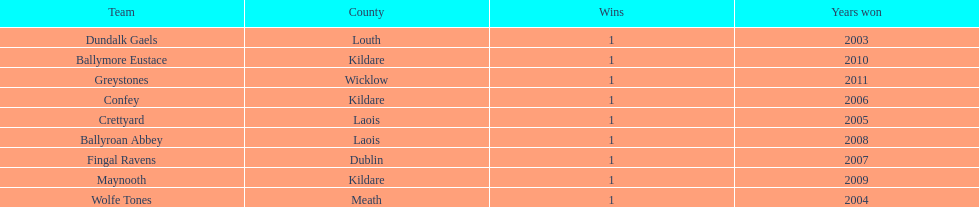Help me parse the entirety of this table. {'header': ['Team', 'County', 'Wins', 'Years won'], 'rows': [['Dundalk Gaels', 'Louth', '1', '2003'], ['Ballymore Eustace', 'Kildare', '1', '2010'], ['Greystones', 'Wicklow', '1', '2011'], ['Confey', 'Kildare', '1', '2006'], ['Crettyard', 'Laois', '1', '2005'], ['Ballyroan Abbey', 'Laois', '1', '2008'], ['Fingal Ravens', 'Dublin', '1', '2007'], ['Maynooth', 'Kildare', '1', '2009'], ['Wolfe Tones', 'Meath', '1', '2004']]} What is the years won for each team 2011, 2010, 2009, 2008, 2007, 2006, 2005, 2004, 2003. 